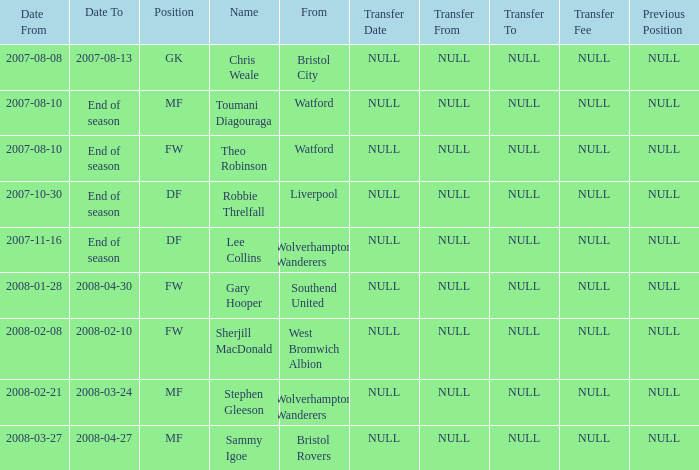What was the from for the Date From of 2007-08-08? Bristol City. Could you help me parse every detail presented in this table? {'header': ['Date From', 'Date To', 'Position', 'Name', 'From', 'Transfer Date', 'Transfer From', 'Transfer To', 'Transfer Fee', 'Previous Position'], 'rows': [['2007-08-08', '2007-08-13', 'GK', 'Chris Weale', 'Bristol City', 'NULL', 'NULL', 'NULL', 'NULL', 'NULL'], ['2007-08-10', 'End of season', 'MF', 'Toumani Diagouraga', 'Watford', 'NULL', 'NULL', 'NULL', 'NULL', 'NULL'], ['2007-08-10', 'End of season', 'FW', 'Theo Robinson', 'Watford', 'NULL', 'NULL', 'NULL', 'NULL', 'NULL'], ['2007-10-30', 'End of season', 'DF', 'Robbie Threlfall', 'Liverpool', 'NULL', 'NULL', 'NULL', 'NULL', 'NULL'], ['2007-11-16', 'End of season', 'DF', 'Lee Collins', 'Wolverhampton Wanderers', 'NULL', 'NULL', 'NULL', 'NULL', 'NULL'], ['2008-01-28', '2008-04-30', 'FW', 'Gary Hooper', 'Southend United', 'NULL', 'NULL', 'NULL', 'NULL', 'NULL'], ['2008-02-08', '2008-02-10', 'FW', 'Sherjill MacDonald', 'West Bromwich Albion', 'NULL', 'NULL', 'NULL', 'NULL', 'NULL'], ['2008-02-21', '2008-03-24', 'MF', 'Stephen Gleeson', 'Wolverhampton Wanderers', 'NULL', 'NULL', 'NULL', 'NULL', 'NULL'], ['2008-03-27', '2008-04-27', 'MF', 'Sammy Igoe', 'Bristol Rovers', 'NULL', 'NULL', 'NULL', 'NULL', 'NULL']]} 